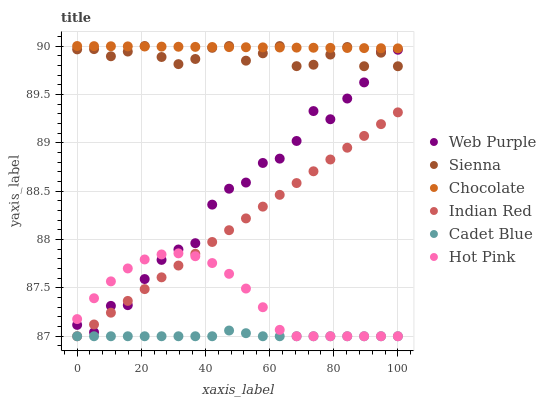Does Cadet Blue have the minimum area under the curve?
Answer yes or no. Yes. Does Chocolate have the maximum area under the curve?
Answer yes or no. Yes. Does Hot Pink have the minimum area under the curve?
Answer yes or no. No. Does Hot Pink have the maximum area under the curve?
Answer yes or no. No. Is Indian Red the smoothest?
Answer yes or no. Yes. Is Web Purple the roughest?
Answer yes or no. Yes. Is Hot Pink the smoothest?
Answer yes or no. No. Is Hot Pink the roughest?
Answer yes or no. No. Does Cadet Blue have the lowest value?
Answer yes or no. Yes. Does Chocolate have the lowest value?
Answer yes or no. No. Does Sienna have the highest value?
Answer yes or no. Yes. Does Hot Pink have the highest value?
Answer yes or no. No. Is Cadet Blue less than Sienna?
Answer yes or no. Yes. Is Web Purple greater than Cadet Blue?
Answer yes or no. Yes. Does Web Purple intersect Indian Red?
Answer yes or no. Yes. Is Web Purple less than Indian Red?
Answer yes or no. No. Is Web Purple greater than Indian Red?
Answer yes or no. No. Does Cadet Blue intersect Sienna?
Answer yes or no. No. 